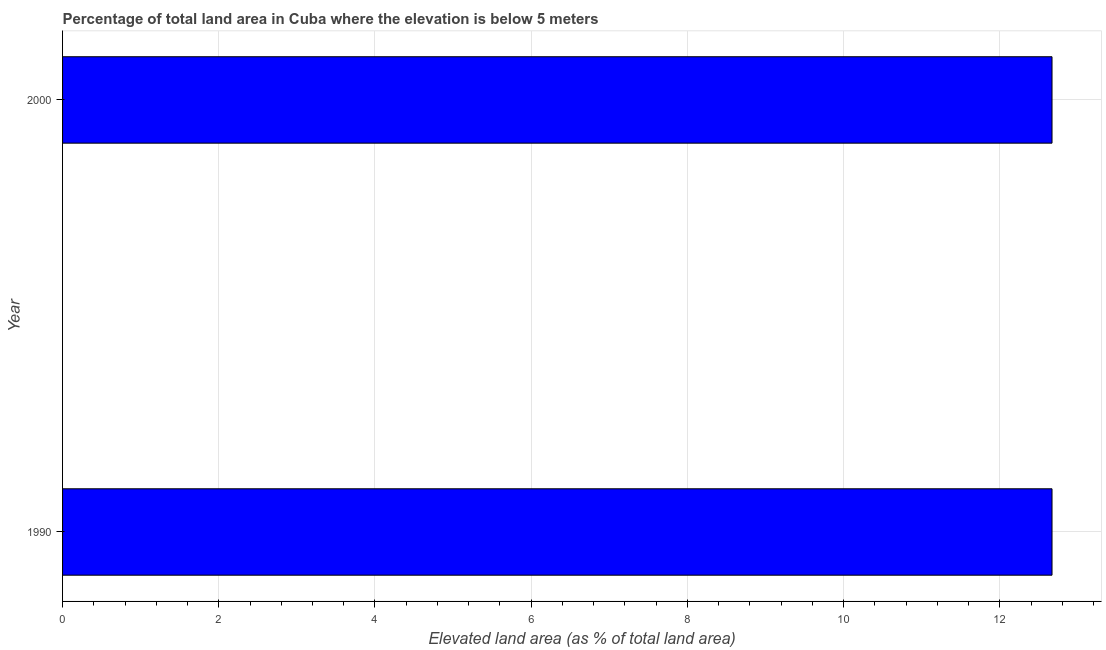What is the title of the graph?
Your response must be concise. Percentage of total land area in Cuba where the elevation is below 5 meters. What is the label or title of the X-axis?
Your answer should be compact. Elevated land area (as % of total land area). What is the total elevated land area in 2000?
Provide a succinct answer. 12.67. Across all years, what is the maximum total elevated land area?
Offer a very short reply. 12.67. Across all years, what is the minimum total elevated land area?
Make the answer very short. 12.67. In which year was the total elevated land area maximum?
Give a very brief answer. 1990. In which year was the total elevated land area minimum?
Your answer should be compact. 1990. What is the sum of the total elevated land area?
Give a very brief answer. 25.34. What is the difference between the total elevated land area in 1990 and 2000?
Provide a succinct answer. 0. What is the average total elevated land area per year?
Provide a succinct answer. 12.67. What is the median total elevated land area?
Provide a short and direct response. 12.67. In how many years, is the total elevated land area greater than 10.8 %?
Provide a short and direct response. 2. Do a majority of the years between 1990 and 2000 (inclusive) have total elevated land area greater than 6.8 %?
Your answer should be compact. Yes. What is the ratio of the total elevated land area in 1990 to that in 2000?
Ensure brevity in your answer.  1. Is the total elevated land area in 1990 less than that in 2000?
Provide a short and direct response. No. In how many years, is the total elevated land area greater than the average total elevated land area taken over all years?
Give a very brief answer. 0. Are all the bars in the graph horizontal?
Make the answer very short. Yes. How many years are there in the graph?
Give a very brief answer. 2. What is the difference between two consecutive major ticks on the X-axis?
Your answer should be compact. 2. What is the Elevated land area (as % of total land area) of 1990?
Provide a short and direct response. 12.67. What is the Elevated land area (as % of total land area) in 2000?
Give a very brief answer. 12.67. 